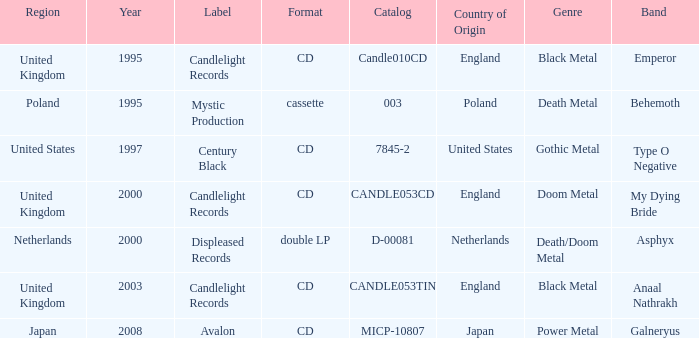What year did Japan form a label? 2008.0. 